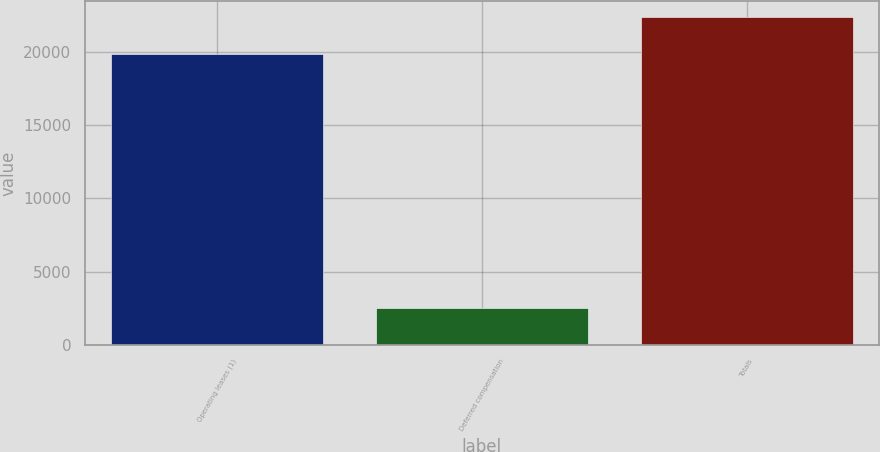Convert chart. <chart><loc_0><loc_0><loc_500><loc_500><bar_chart><fcel>Operating leases (1)<fcel>Deferred compensation<fcel>Totals<nl><fcel>19821<fcel>2518<fcel>22339<nl></chart> 